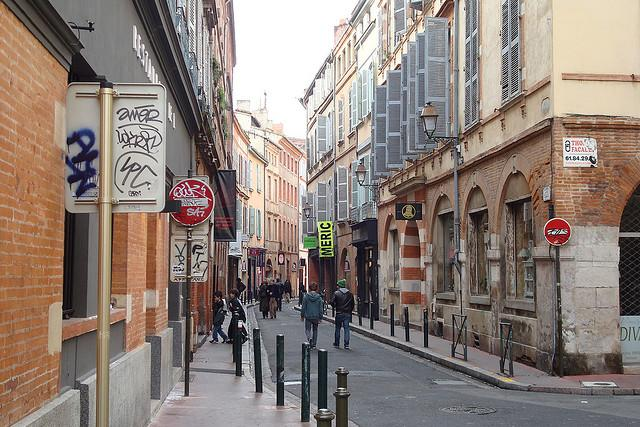What damage has been done in this street? graffiti 